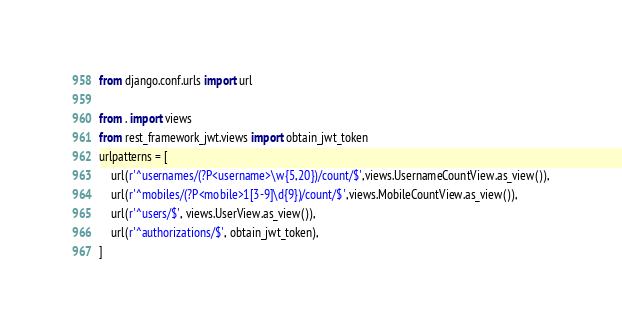Convert code to text. <code><loc_0><loc_0><loc_500><loc_500><_Python_>from django.conf.urls import url

from . import views
from rest_framework_jwt.views import obtain_jwt_token
urlpatterns = [
    url(r'^usernames/(?P<username>\w{5,20})/count/$',views.UsernameCountView.as_view()),
    url(r'^mobiles/(?P<mobile>1[3-9]\d{9})/count/$',views.MobileCountView.as_view()),
    url(r'^users/$', views.UserView.as_view()),
    url(r'^authorizations/$', obtain_jwt_token),
]</code> 